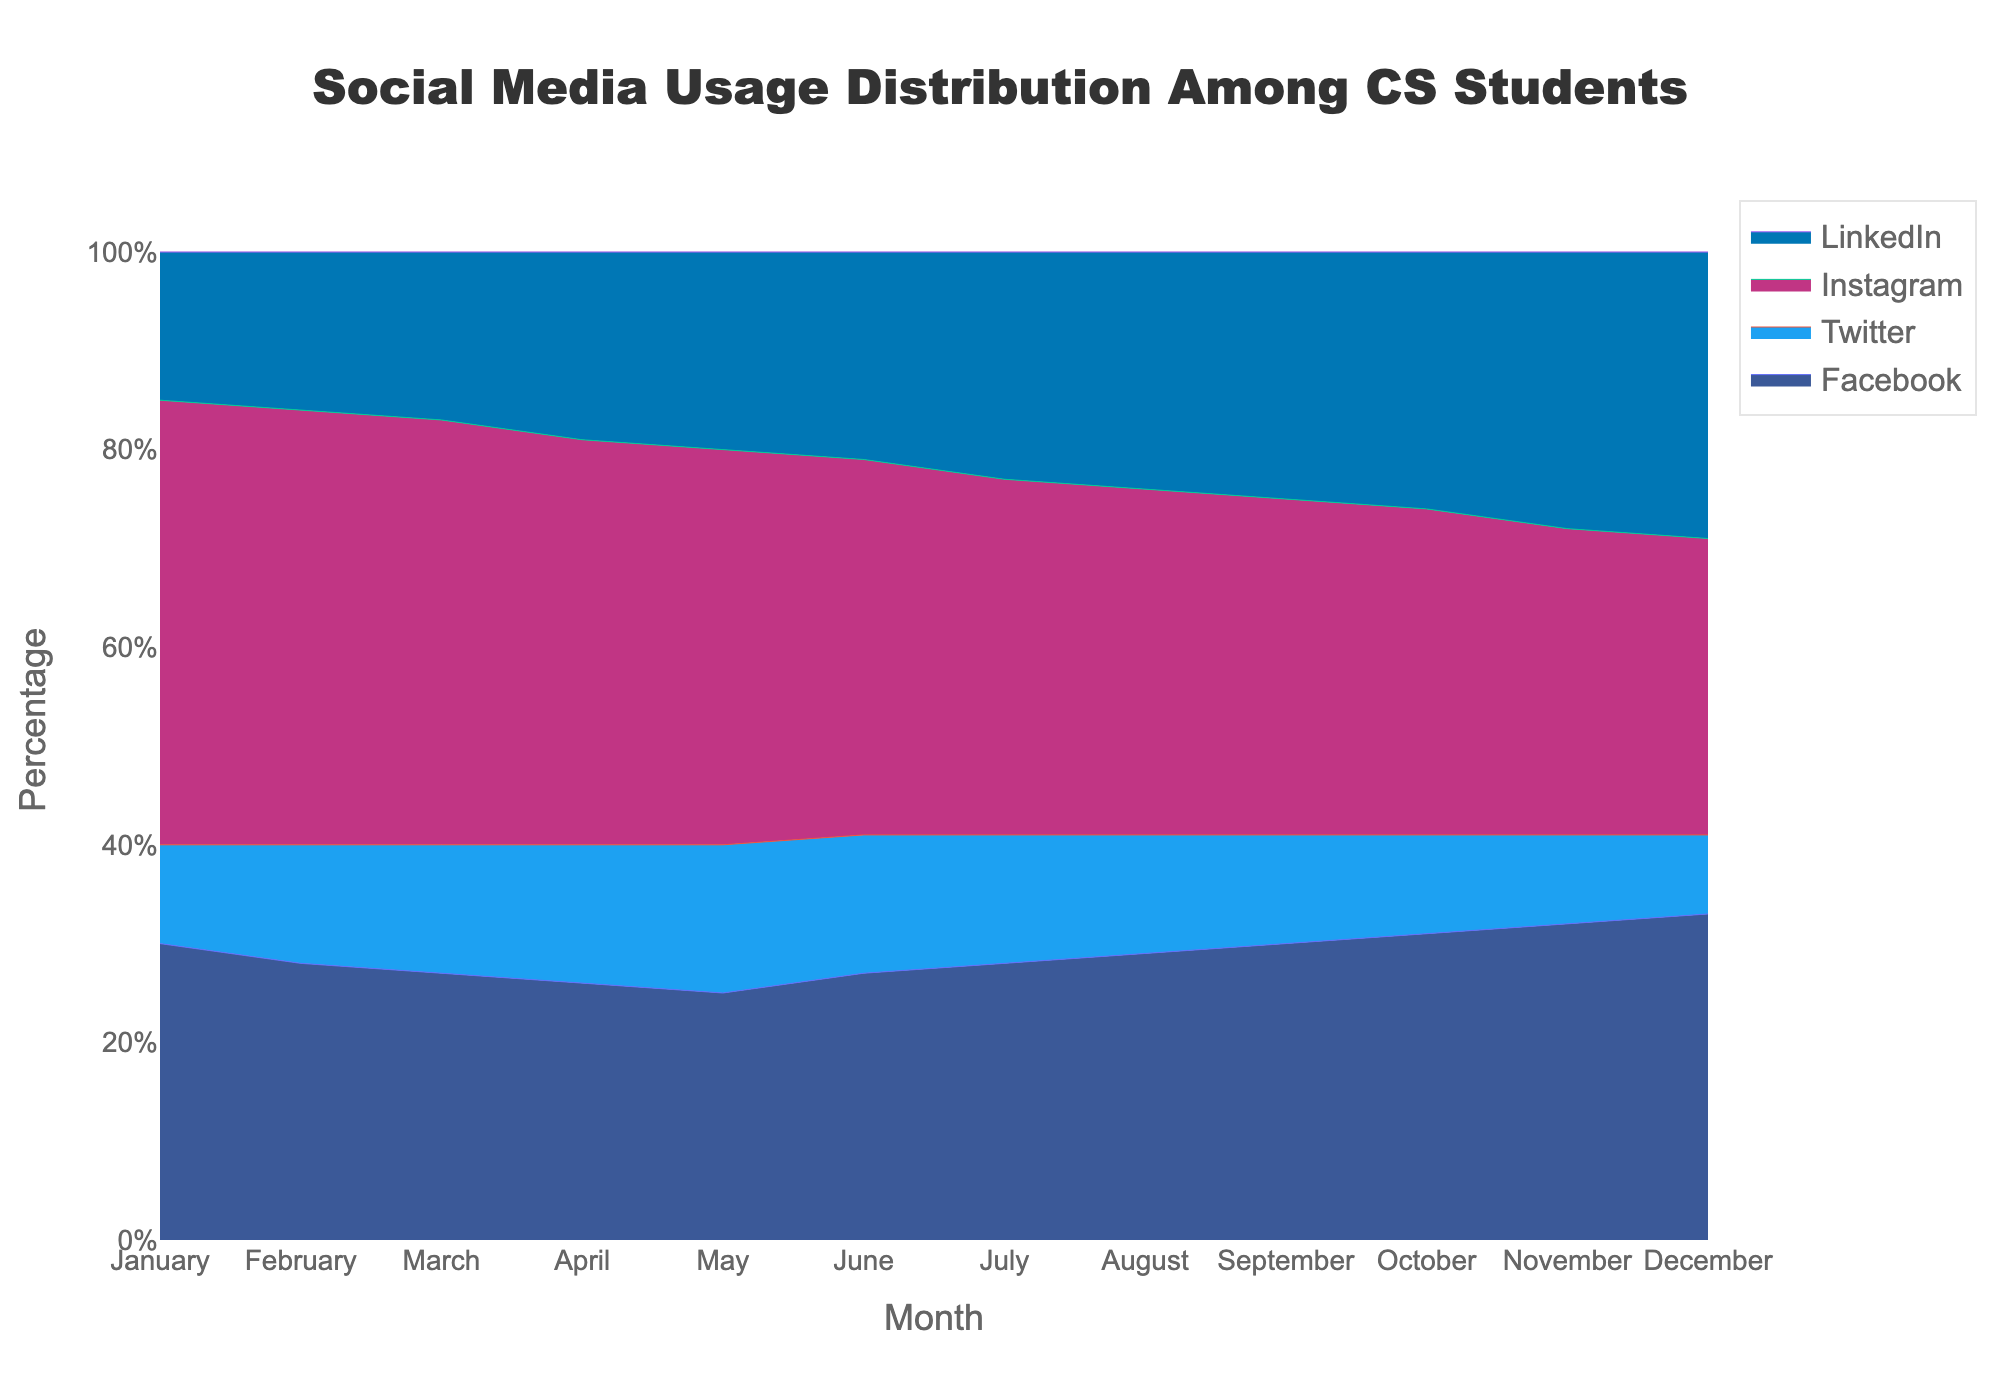What is the title of the chart? The title of the chart is displayed at the top of the figure and typically describes the main subject of the data shown.
Answer: Social Media Usage Distribution Among CS Students What is the color coding for Instagram usage in the chart? The color coding for Instagram usage is represented consistently throughout the figure. By examining the legend, it indicates Instagram is shown in pink.
Answer: Pink In which month does Facebook have the highest percentage of usage? Look at the y-axis values for the Facebook area across the months. The highest point indicates the maximum percentage for Facebook.
Answer: December What is the percentage of Twitter usage in November? Find the month of November on the x-axis, then look at the corresponding y-axis value for Twitter, which is shown in light blue.
Answer: 9% Comparing April and August, in which month is LinkedIn usage higher? Identify the layers for LinkedIn for April and August. Compare the heights of the LinkedIn area for these months.
Answer: August Which platform shows a decreasing trend in usage throughout the year? Examine the lines for all platforms from January to December. Identify which line consistently slopes downward.
Answer: Twitter What is the total percentage of usage for Facebook and Instagram in January? Add the percentage values for Facebook and Instagram for January from the data points provided.
Answer: 75% How does the usage of LinkedIn change from June to July? Compare the y-axis value for LinkedIn in June with the one in July. Determine whether it increases, decreases, or stays the same.
Answer: Increases Which social media platform has the least variation in usage over the year? Observe the fluctuations for each platform throughout the year. The platform with the smallest changes (smallest range) in percentage is identified.
Answer: Twitter What is the average LinkedIn usage across the entire year? Sum up the LinkedIn usage percentages for all months, then divide by the number of months (12).
Answer: 22% 